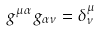<formula> <loc_0><loc_0><loc_500><loc_500>g ^ { \mu \alpha } g _ { \alpha \nu } = \delta _ { \nu } ^ { \mu }</formula> 